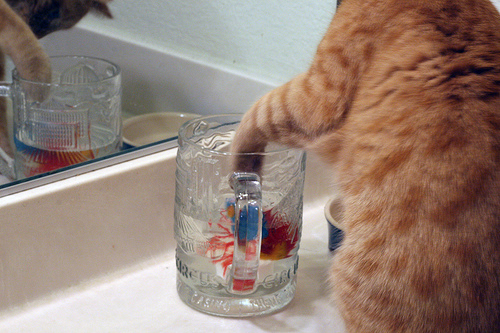<image>
Is there a cat in the glass? No. The cat is not contained within the glass. These objects have a different spatial relationship. 